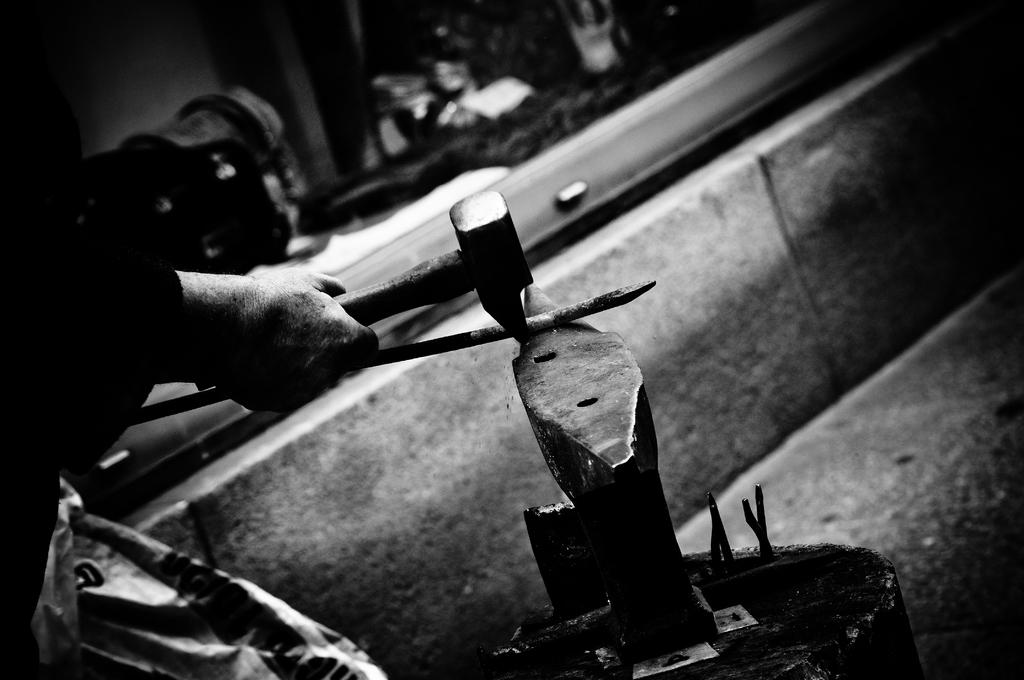What can be seen in the image? There is a person in the image. What is the person doing in the image? The person is holding an object. Can you describe the background of the image? The background of the image is blurred. What is the color scheme of the image? The image is in black and white. What type of weather can be seen in the image? The image is in black and white, and there is no indication of weather in the image. 